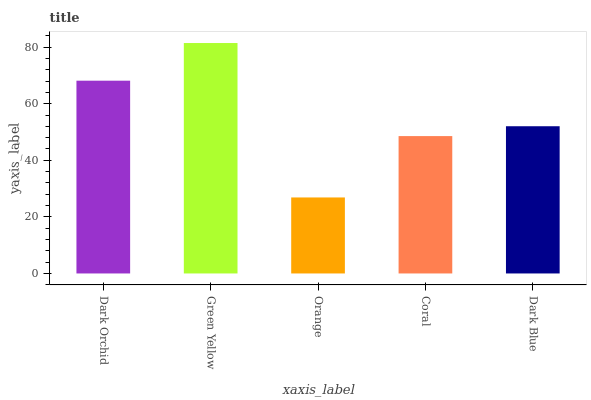Is Orange the minimum?
Answer yes or no. Yes. Is Green Yellow the maximum?
Answer yes or no. Yes. Is Green Yellow the minimum?
Answer yes or no. No. Is Orange the maximum?
Answer yes or no. No. Is Green Yellow greater than Orange?
Answer yes or no. Yes. Is Orange less than Green Yellow?
Answer yes or no. Yes. Is Orange greater than Green Yellow?
Answer yes or no. No. Is Green Yellow less than Orange?
Answer yes or no. No. Is Dark Blue the high median?
Answer yes or no. Yes. Is Dark Blue the low median?
Answer yes or no. Yes. Is Coral the high median?
Answer yes or no. No. Is Dark Orchid the low median?
Answer yes or no. No. 